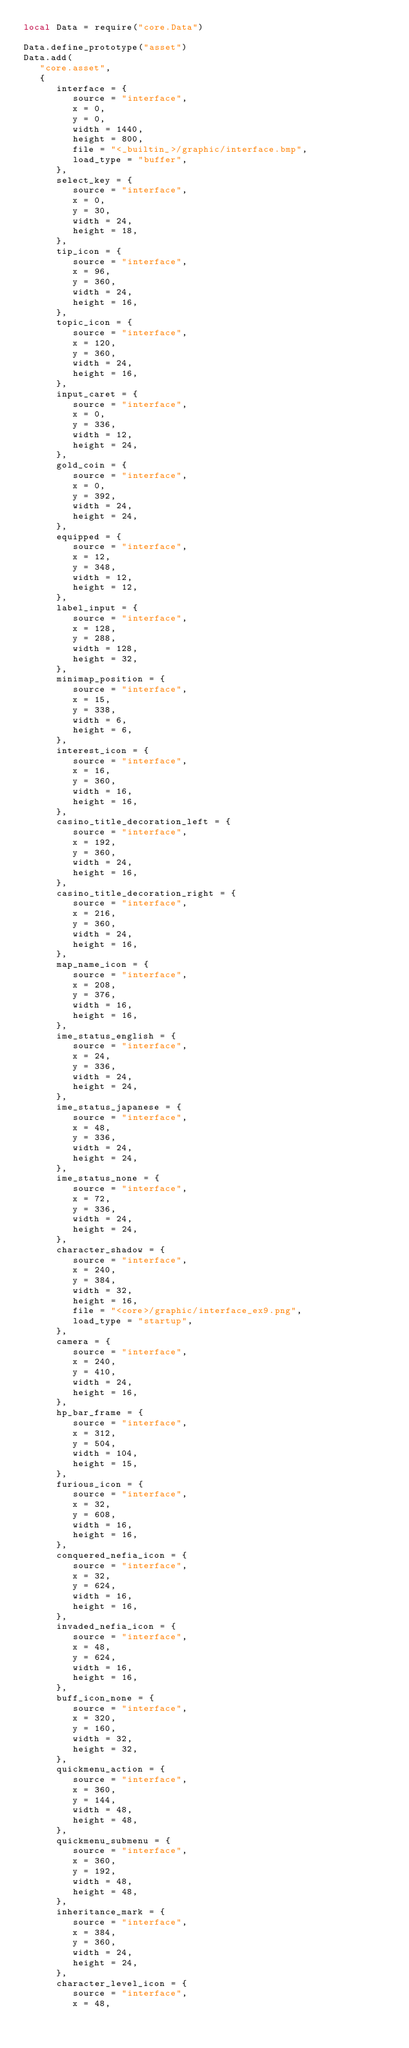Convert code to text. <code><loc_0><loc_0><loc_500><loc_500><_Lua_>local Data = require("core.Data")

Data.define_prototype("asset")
Data.add(
   "core.asset",
   {
      interface = {
         source = "interface",
         x = 0,
         y = 0,
         width = 1440,
         height = 800,
         file = "<_builtin_>/graphic/interface.bmp",
         load_type = "buffer",
      },
      select_key = {
         source = "interface",
         x = 0,
         y = 30,
         width = 24,
         height = 18,
      },
      tip_icon = {
         source = "interface",
         x = 96,
         y = 360,
         width = 24,
         height = 16,
      },
      topic_icon = {
         source = "interface",
         x = 120,
         y = 360,
         width = 24,
         height = 16,
      },
      input_caret = {
         source = "interface",
         x = 0,
         y = 336,
         width = 12,
         height = 24,
      },
      gold_coin = {
         source = "interface",
         x = 0,
         y = 392,
         width = 24,
         height = 24,
      },
      equipped = {
         source = "interface",
         x = 12,
         y = 348,
         width = 12,
         height = 12,
      },
      label_input = {
         source = "interface",
         x = 128,
         y = 288,
         width = 128,
         height = 32,
      },
      minimap_position = {
         source = "interface",
         x = 15,
         y = 338,
         width = 6,
         height = 6,
      },
      interest_icon = {
         source = "interface",
         x = 16,
         y = 360,
         width = 16,
         height = 16,
      },
      casino_title_decoration_left = {
         source = "interface",
         x = 192,
         y = 360,
         width = 24,
         height = 16,
      },
      casino_title_decoration_right = {
         source = "interface",
         x = 216,
         y = 360,
         width = 24,
         height = 16,
      },
      map_name_icon = {
         source = "interface",
         x = 208,
         y = 376,
         width = 16,
         height = 16,
      },
      ime_status_english = {
         source = "interface",
         x = 24,
         y = 336,
         width = 24,
         height = 24,
      },
      ime_status_japanese = {
         source = "interface",
         x = 48,
         y = 336,
         width = 24,
         height = 24,
      },
      ime_status_none = {
         source = "interface",
         x = 72,
         y = 336,
         width = 24,
         height = 24,
      },
      character_shadow = {
         source = "interface",
         x = 240,
         y = 384,
         width = 32,
         height = 16,
         file = "<core>/graphic/interface_ex9.png",
         load_type = "startup",
      },
      camera = {
         source = "interface",
         x = 240,
         y = 410,
         width = 24,
         height = 16,
      },
      hp_bar_frame = {
         source = "interface",
         x = 312,
         y = 504,
         width = 104,
         height = 15,
      },
      furious_icon = {
         source = "interface",
         x = 32,
         y = 608,
         width = 16,
         height = 16,
      },
      conquered_nefia_icon = {
         source = "interface",
         x = 32,
         y = 624,
         width = 16,
         height = 16,
      },
      invaded_nefia_icon = {
         source = "interface",
         x = 48,
         y = 624,
         width = 16,
         height = 16,
      },
      buff_icon_none = {
         source = "interface",
         x = 320,
         y = 160,
         width = 32,
         height = 32,
      },
      quickmenu_action = {
         source = "interface",
         x = 360,
         y = 144,
         width = 48,
         height = 48,
      },
      quickmenu_submenu = {
         source = "interface",
         x = 360,
         y = 192,
         width = 48,
         height = 48,
      },
      inheritance_mark = {
         source = "interface",
         x = 384,
         y = 360,
         width = 24,
         height = 24,
      },
      character_level_icon = {
         source = "interface",
         x = 48,</code> 